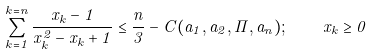<formula> <loc_0><loc_0><loc_500><loc_500>\sum _ { k = 1 } ^ { k = n } \frac { x _ { k } - 1 } { x _ { k } ^ { 2 } - x _ { k } + 1 } \leq \frac { n } { 3 } - C ( a _ { 1 } , a _ { 2 } , \cdots , a _ { n } ) ; \quad x _ { k } \geq 0</formula> 